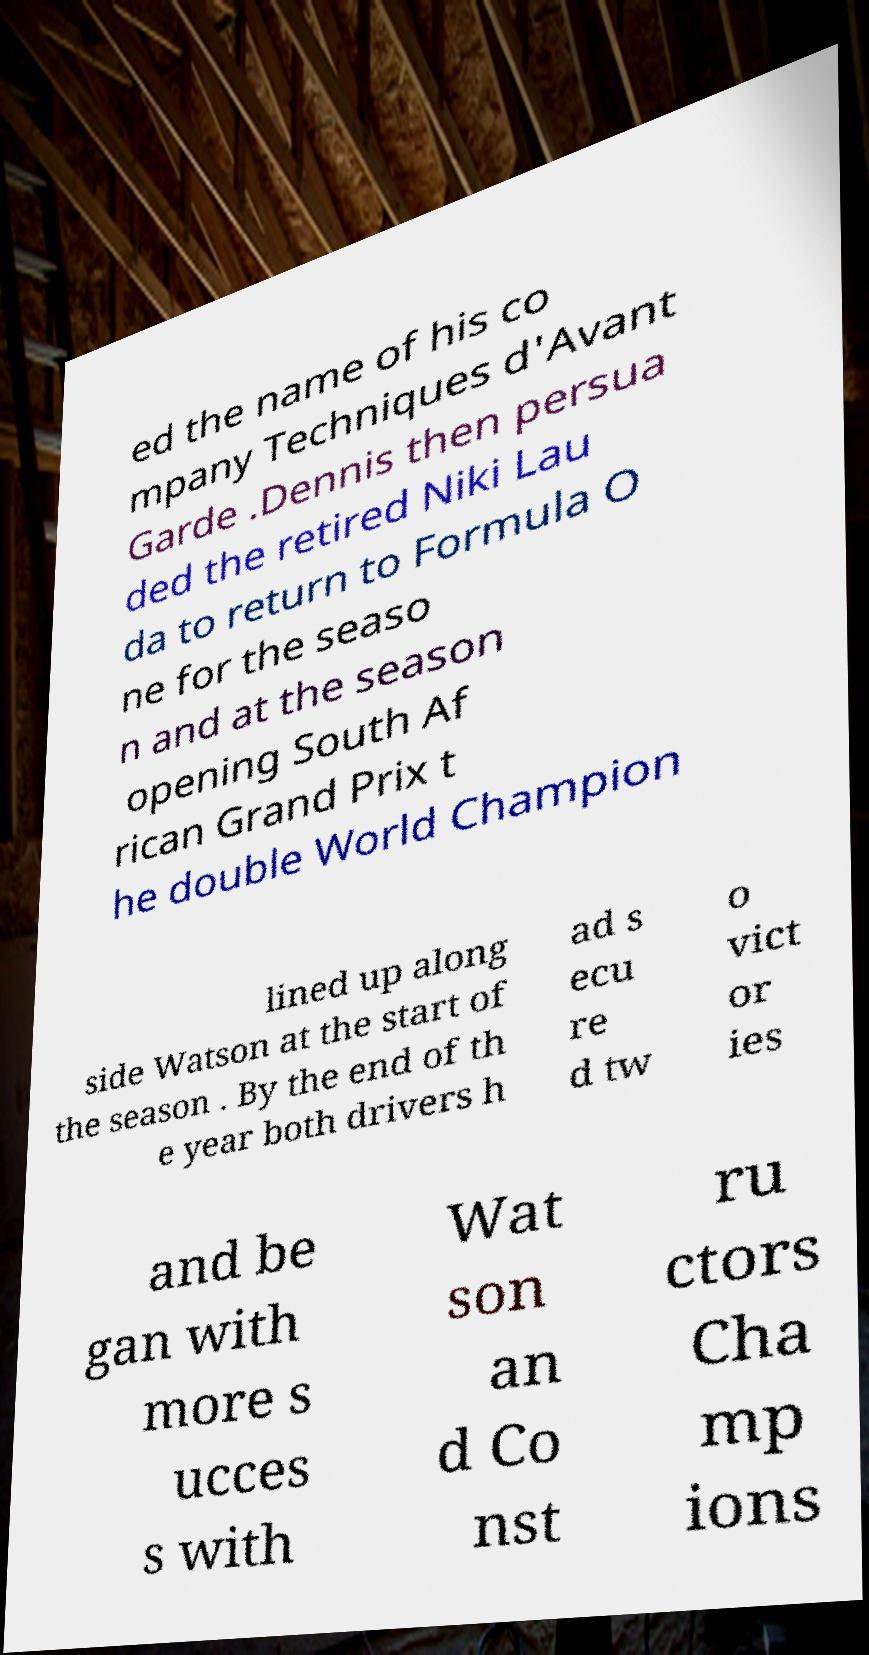Please read and relay the text visible in this image. What does it say? ed the name of his co mpany Techniques d'Avant Garde .Dennis then persua ded the retired Niki Lau da to return to Formula O ne for the seaso n and at the season opening South Af rican Grand Prix t he double World Champion lined up along side Watson at the start of the season . By the end of th e year both drivers h ad s ecu re d tw o vict or ies and be gan with more s ucces s with Wat son an d Co nst ru ctors Cha mp ions 